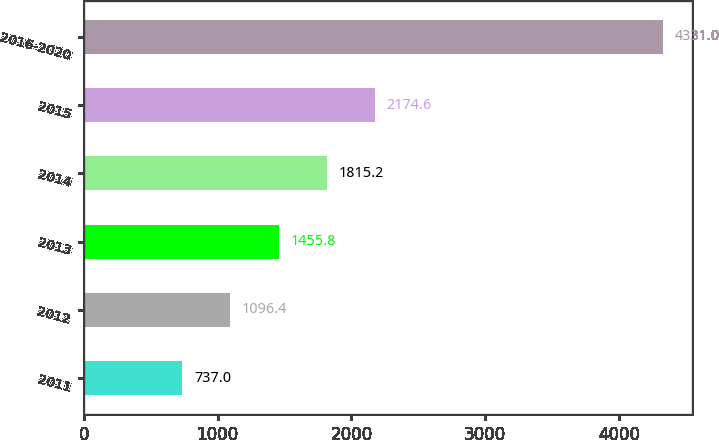<chart> <loc_0><loc_0><loc_500><loc_500><bar_chart><fcel>2011<fcel>2012<fcel>2013<fcel>2014<fcel>2015<fcel>2016-2020<nl><fcel>737<fcel>1096.4<fcel>1455.8<fcel>1815.2<fcel>2174.6<fcel>4331<nl></chart> 